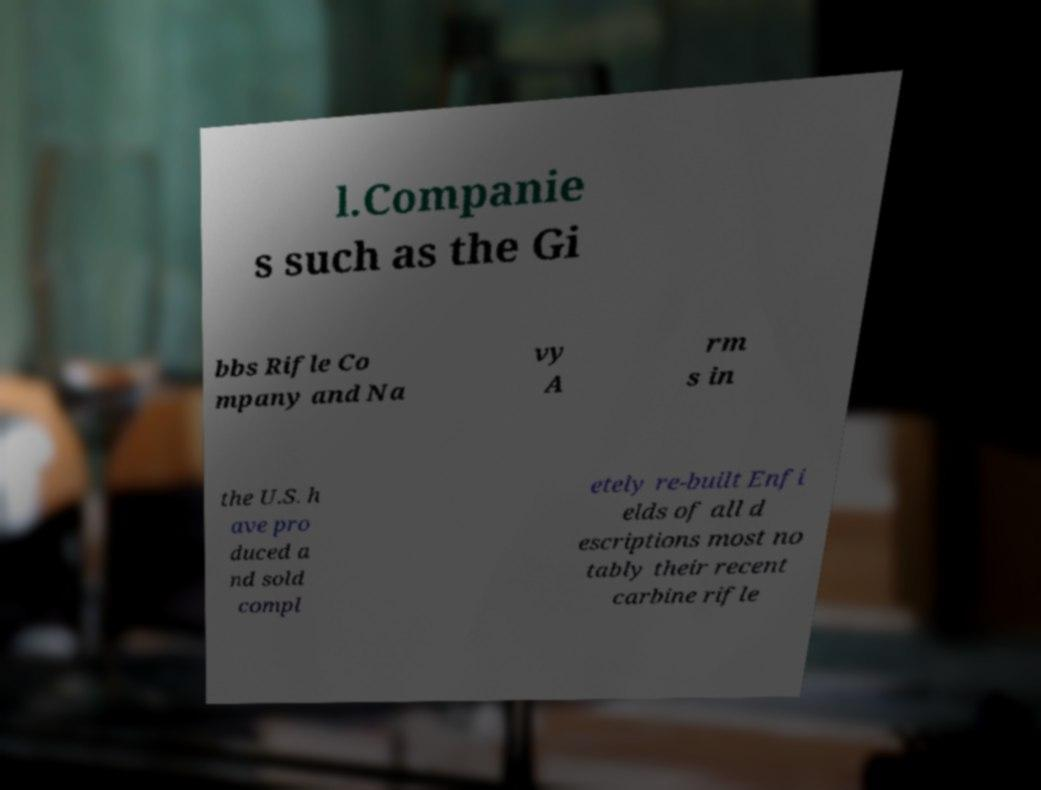Could you extract and type out the text from this image? l.Companie s such as the Gi bbs Rifle Co mpany and Na vy A rm s in the U.S. h ave pro duced a nd sold compl etely re-built Enfi elds of all d escriptions most no tably their recent carbine rifle 